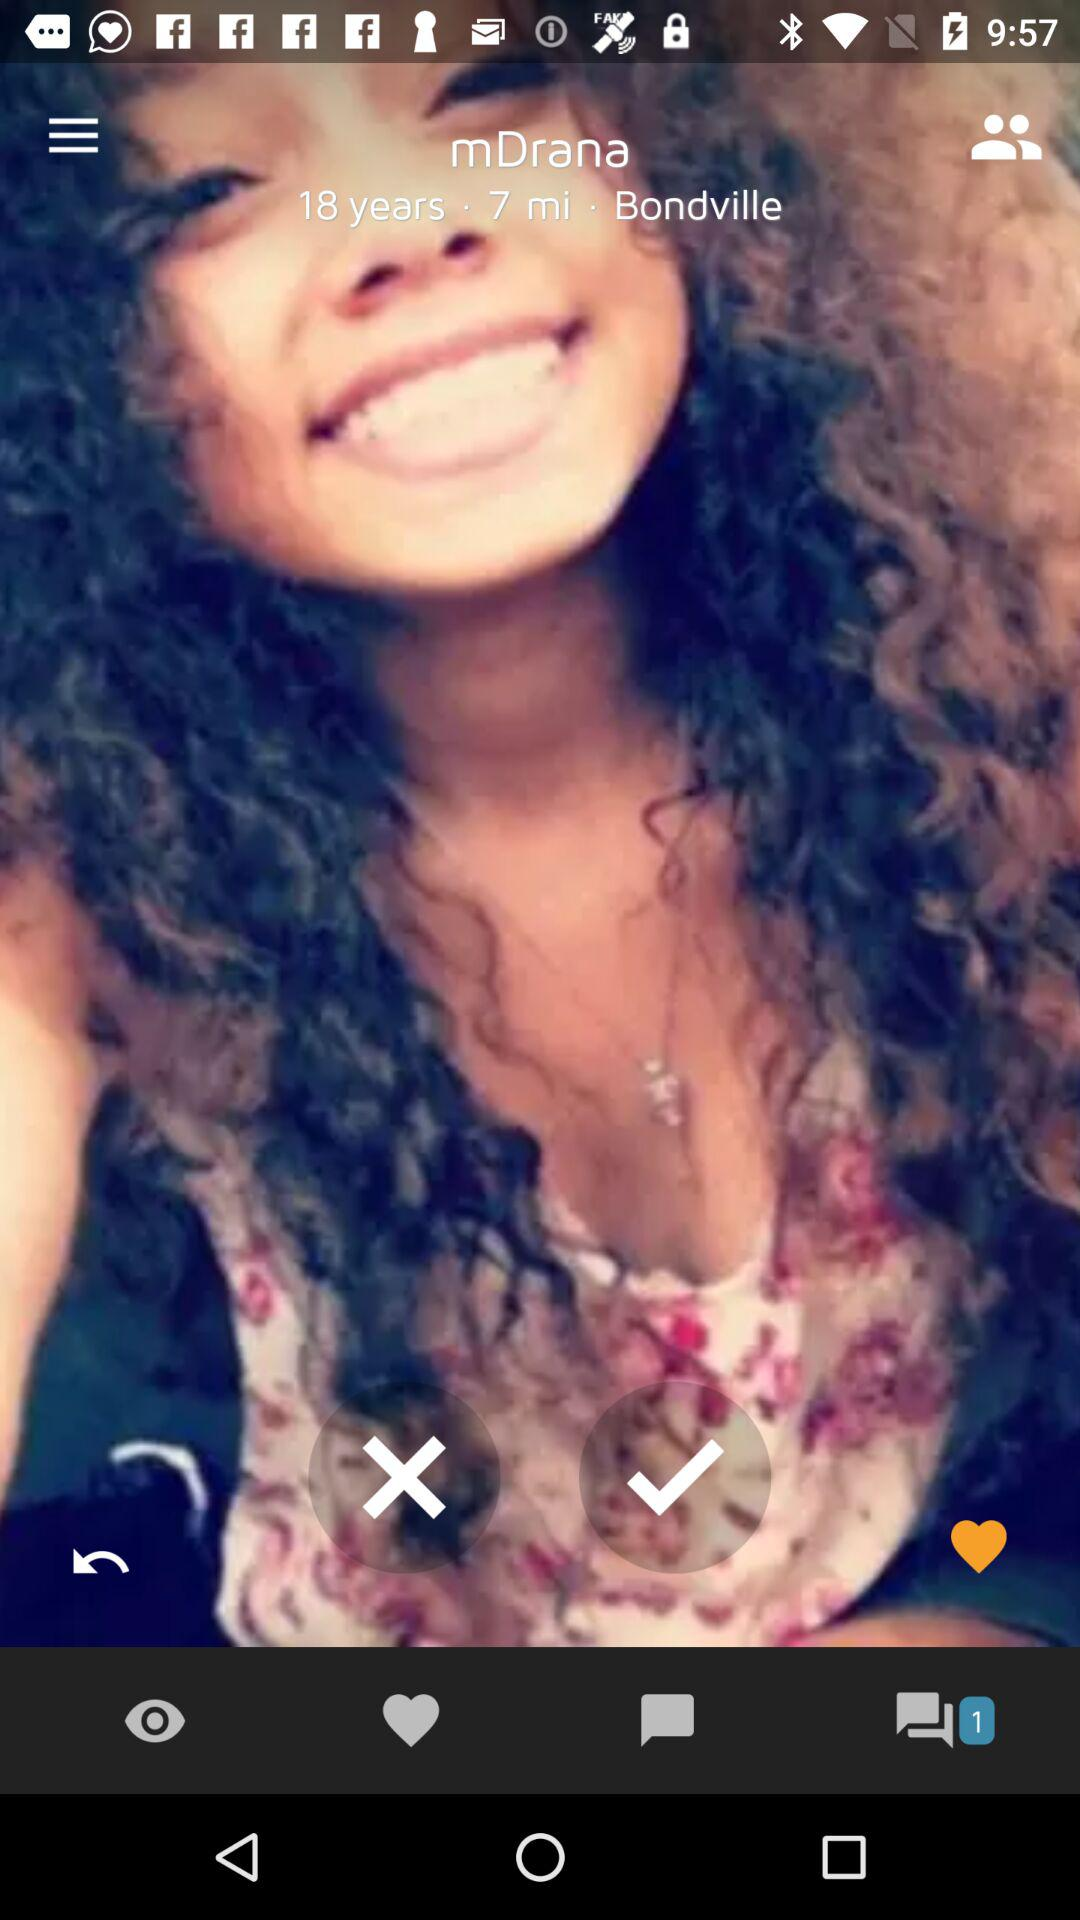How many notifications are there in the chat? There is 1 notification. 